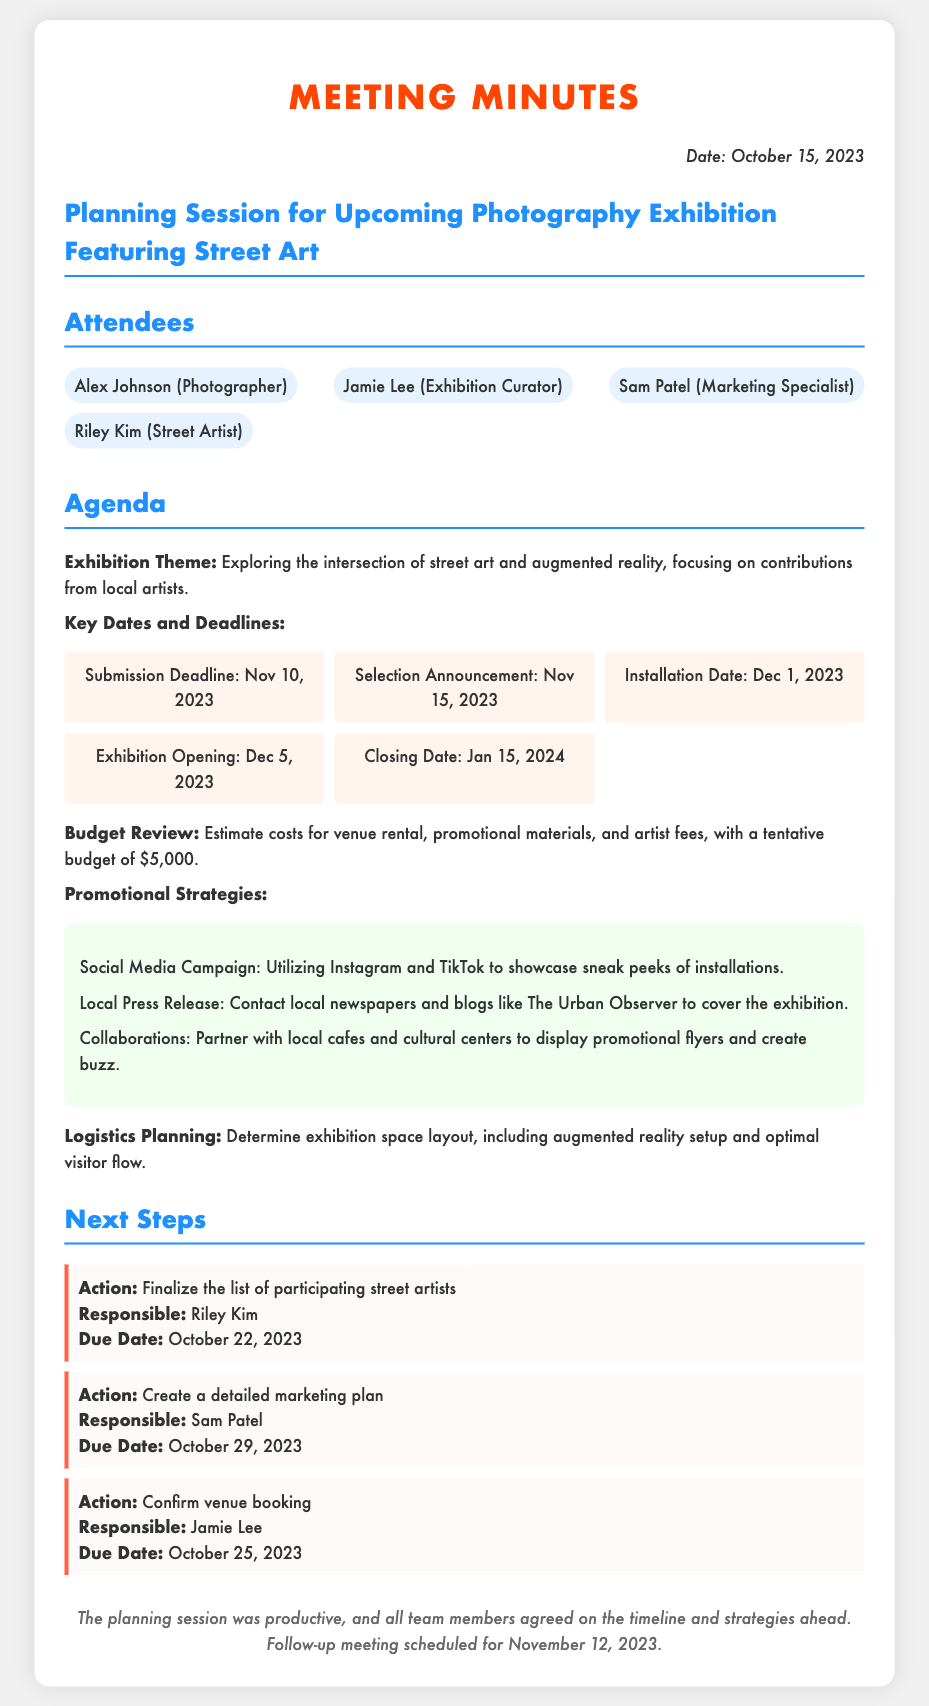What is the exhibition theme? The exhibition theme is about exploring the intersection of street art and augmented reality, which is mentioned in the agenda section.
Answer: Intersection of street art and augmented reality When is the submission deadline? The submission deadline is listed among the key dates under the deadlines section.
Answer: November 10, 2023 Who is responsible for finalizing the list of participating street artists? The document specifies that Riley Kim is responsible for this action under next steps.
Answer: Riley Kim What is the tentative budget for the exhibition? The budget is stated in the agenda section, highlighting the estimated costs for various aspects of the exhibition.
Answer: $5,000 What is the exhibition opening date? The exhibition opening date can be found within the key dates section of the document.
Answer: December 5, 2023 How many promotional strategies are listed? The number of promotional strategies is determined by counting the items listed in the promotional strategies section.
Answer: Three What is the due date for confirming the venue booking? The due date for venue booking is included in the next steps section under the action for Jamie Lee.
Answer: October 25, 2023 When is the follow-up meeting scheduled? The follow-up meeting date is mentioned in the closing remarks of the document.
Answer: November 12, 2023 